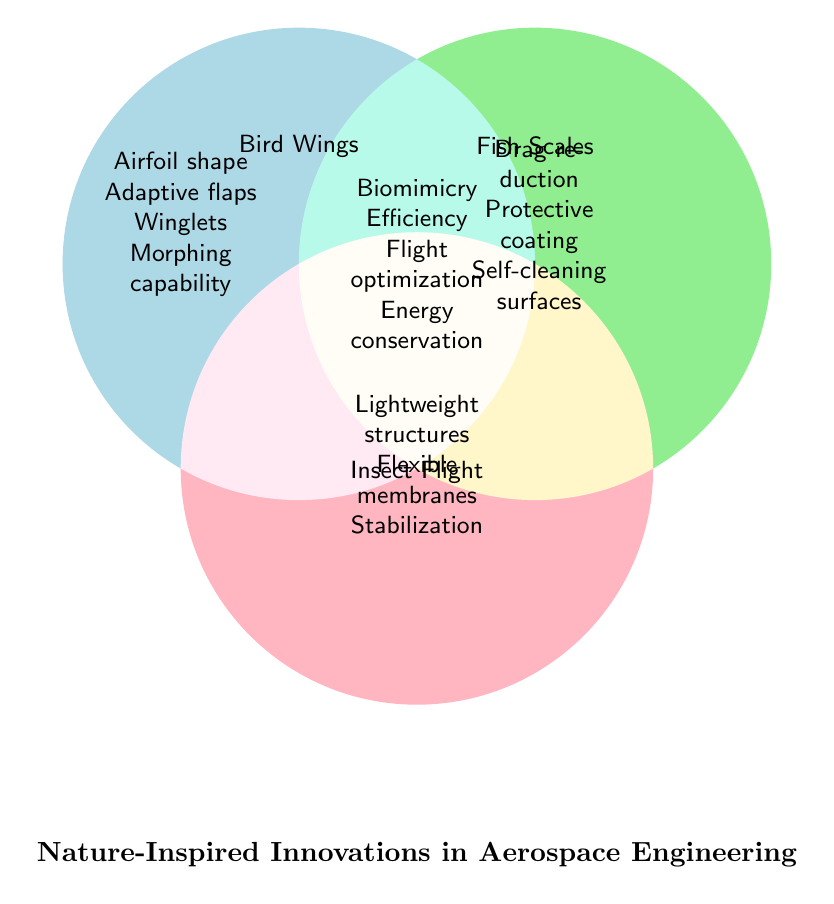What's the title of the Venn Diagram? The title is typically located beneath or above the main figure elements in a legible font size. Here, it is located at the bottom center of the diagram.
Answer: Nature-Inspired Innovations in Aerospace Engineering Which innovation is common between all three categories? In a Venn Diagram, the intersection where all three circles overlap represents elements common to all categories.
Answer: Biomimicry, Efficiency, Flight optimization, Energy conservation What innovations are unique to Bird Wings? Unique elements for Bird Wings are placed within the Bird Wings circle but outside the overlapping areas with other circles.
Answer: Airfoil shape, Adaptive flaps, Winglets, Morphing capability Which area has the most listed innovations? Count the number of listed items in each section to determine the area with the most innovations. The areas of interest are the unique sections and intersections of the circles.
Answer: Common (4 elements) Do Bird Wings and Fish Scales share any innovations? If so, which are they? For shared innovations between two categories, look at the intersecting area between the two respective circles.
Answer: None Which innovations are common between Bird Wings and Insect Flight? The intersection area between Bird Wings and Insect Flight sections contains the shared innovations.
Answer: Stabilization Name an innovation that is shared between Fish Scales and Insect Flight. This should be identified from the overlapping area between Fish Scales and Insect Flight circles.
Answer: There is no shared innovation between Fish Scales and Insect Flight How many unique innovations are listed in the Fish Scales category? Count the number of elements that fall solely within the Fish Scales circle and do not overlap with any other areas.
Answer: Three Which aspect is NOT included for Bird Wings? By checking the Berry Wings circle and cross-referencing with the category list, determine which characteristic isn't mentioned for Bird Wings.
Answer: Self-cleaning surfaces In which categories do "Self-cleaning surfaces" and "Drag reduction" fall under? Check the elements listed within the intersections or unique areas of each respective circle to place each term correctly.
Answer: Fish Scales 